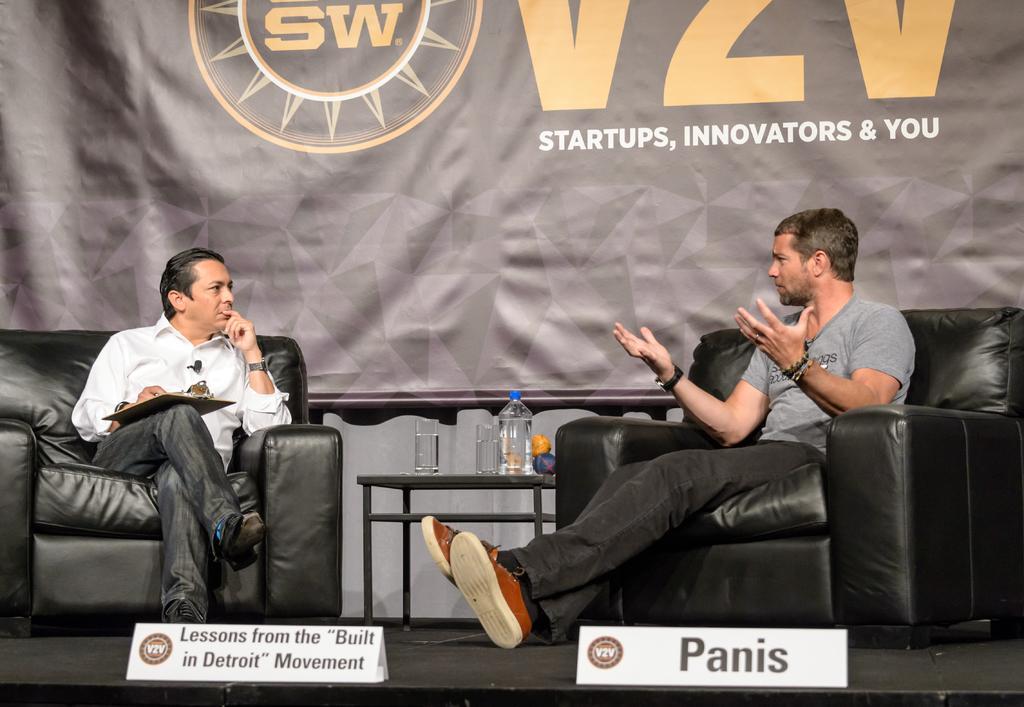How would you summarize this image in a sentence or two? In the picture we can see two men are sitting on the black colored sofa, chairs and one man is talking with actions and one man is nothing in the paper and between them we can see a small table on it, we can see a water bottle and two glasses and in the background we can see a banner which is black in color with some advertisement on it. 